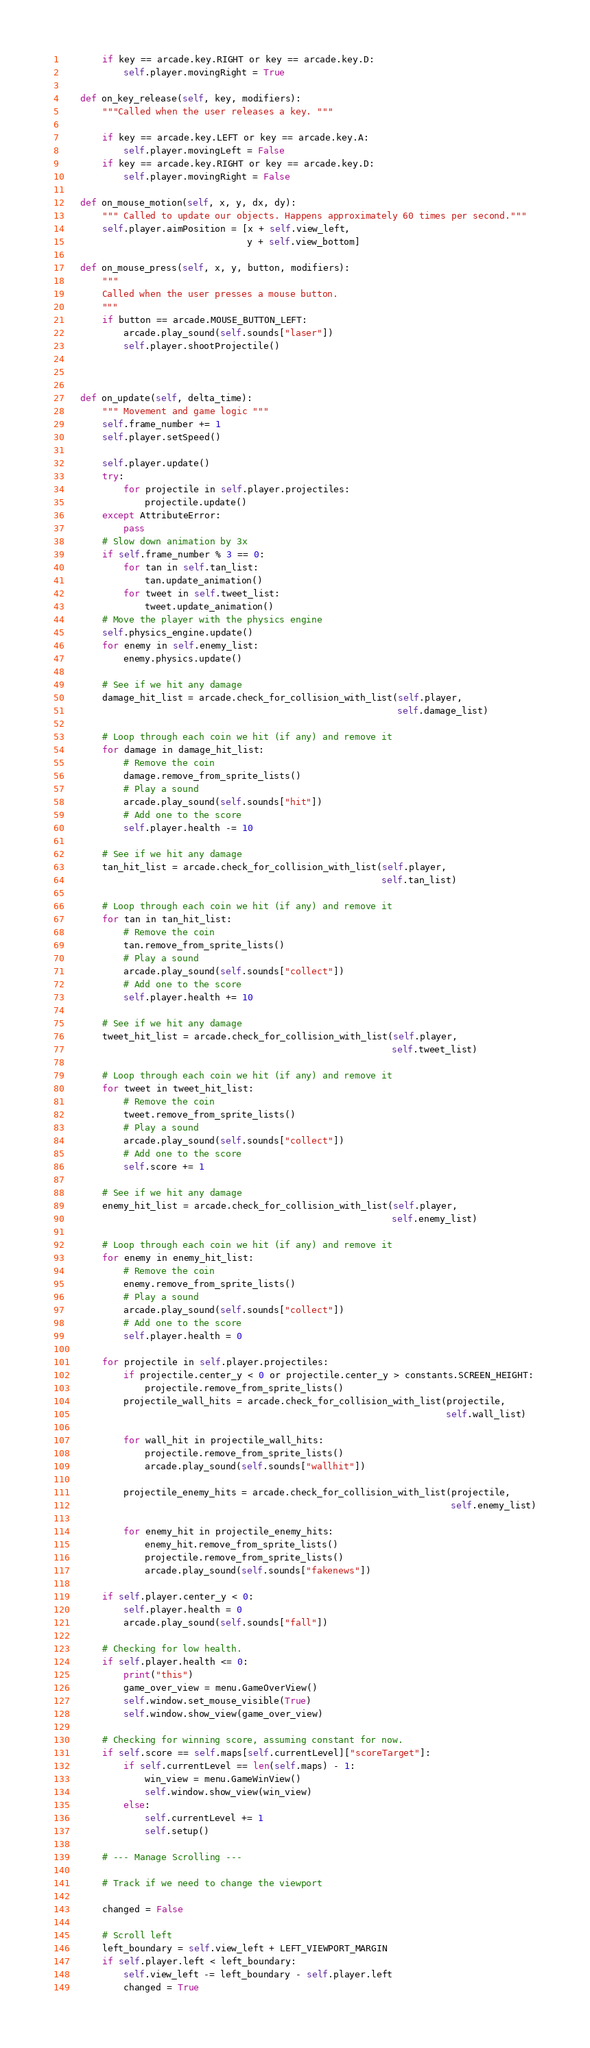<code> <loc_0><loc_0><loc_500><loc_500><_Python_>        if key == arcade.key.RIGHT or key == arcade.key.D:
            self.player.movingRight = True

    def on_key_release(self, key, modifiers):
        """Called when the user releases a key. """

        if key == arcade.key.LEFT or key == arcade.key.A:
            self.player.movingLeft = False
        if key == arcade.key.RIGHT or key == arcade.key.D:
            self.player.movingRight = False

    def on_mouse_motion(self, x, y, dx, dy):
        """ Called to update our objects. Happens approximately 60 times per second."""
        self.player.aimPosition = [x + self.view_left,
                                   y + self.view_bottom]

    def on_mouse_press(self, x, y, button, modifiers):
        """
        Called when the user presses a mouse button.
        """
        if button == arcade.MOUSE_BUTTON_LEFT:
            arcade.play_sound(self.sounds["laser"])
            self.player.shootProjectile()



    def on_update(self, delta_time):
        """ Movement and game logic """
        self.frame_number += 1
        self.player.setSpeed()

        self.player.update()
        try:
            for projectile in self.player.projectiles:
                projectile.update()
        except AttributeError:
            pass
        # Slow down animation by 3x
        if self.frame_number % 3 == 0:
            for tan in self.tan_list:
                tan.update_animation()
            for tweet in self.tweet_list:
                tweet.update_animation()
        # Move the player with the physics engine
        self.physics_engine.update()
        for enemy in self.enemy_list:
            enemy.physics.update()

        # See if we hit any damage
        damage_hit_list = arcade.check_for_collision_with_list(self.player,
                                                               self.damage_list)

        # Loop through each coin we hit (if any) and remove it
        for damage in damage_hit_list:
            # Remove the coin
            damage.remove_from_sprite_lists()
            # Play a sound
            arcade.play_sound(self.sounds["hit"])
            # Add one to the score
            self.player.health -= 10

        # See if we hit any damage
        tan_hit_list = arcade.check_for_collision_with_list(self.player,
                                                            self.tan_list)

        # Loop through each coin we hit (if any) and remove it
        for tan in tan_hit_list:
            # Remove the coin
            tan.remove_from_sprite_lists()
            # Play a sound
            arcade.play_sound(self.sounds["collect"])
            # Add one to the score
            self.player.health += 10

        # See if we hit any damage
        tweet_hit_list = arcade.check_for_collision_with_list(self.player,
                                                              self.tweet_list)

        # Loop through each coin we hit (if any) and remove it
        for tweet in tweet_hit_list:
            # Remove the coin
            tweet.remove_from_sprite_lists()
            # Play a sound
            arcade.play_sound(self.sounds["collect"])
            # Add one to the score
            self.score += 1

        # See if we hit any damage
        enemy_hit_list = arcade.check_for_collision_with_list(self.player,
                                                              self.enemy_list)

        # Loop through each coin we hit (if any) and remove it
        for enemy in enemy_hit_list:
            # Remove the coin
            enemy.remove_from_sprite_lists()
            # Play a sound
            arcade.play_sound(self.sounds["collect"])
            # Add one to the score
            self.player.health = 0

        for projectile in self.player.projectiles:
            if projectile.center_y < 0 or projectile.center_y > constants.SCREEN_HEIGHT:
                projectile.remove_from_sprite_lists()
            projectile_wall_hits = arcade.check_for_collision_with_list(projectile,
                                                                        self.wall_list)

            for wall_hit in projectile_wall_hits:
                projectile.remove_from_sprite_lists()
                arcade.play_sound(self.sounds["wallhit"])

            projectile_enemy_hits = arcade.check_for_collision_with_list(projectile,
                                                                         self.enemy_list)

            for enemy_hit in projectile_enemy_hits:
                enemy_hit.remove_from_sprite_lists()
                projectile.remove_from_sprite_lists()
                arcade.play_sound(self.sounds["fakenews"])

        if self.player.center_y < 0:
            self.player.health = 0
            arcade.play_sound(self.sounds["fall"])

        # Checking for low health.
        if self.player.health <= 0:
            print("this")
            game_over_view = menu.GameOverView()
            self.window.set_mouse_visible(True)
            self.window.show_view(game_over_view)

        # Checking for winning score, assuming constant for now.
        if self.score == self.maps[self.currentLevel]["scoreTarget"]:
            if self.currentLevel == len(self.maps) - 1:
                win_view = menu.GameWinView()
                self.window.show_view(win_view)
            else:
                self.currentLevel += 1
                self.setup()

        # --- Manage Scrolling ---

        # Track if we need to change the viewport

        changed = False

        # Scroll left
        left_boundary = self.view_left + LEFT_VIEWPORT_MARGIN
        if self.player.left < left_boundary:
            self.view_left -= left_boundary - self.player.left
            changed = True
</code> 